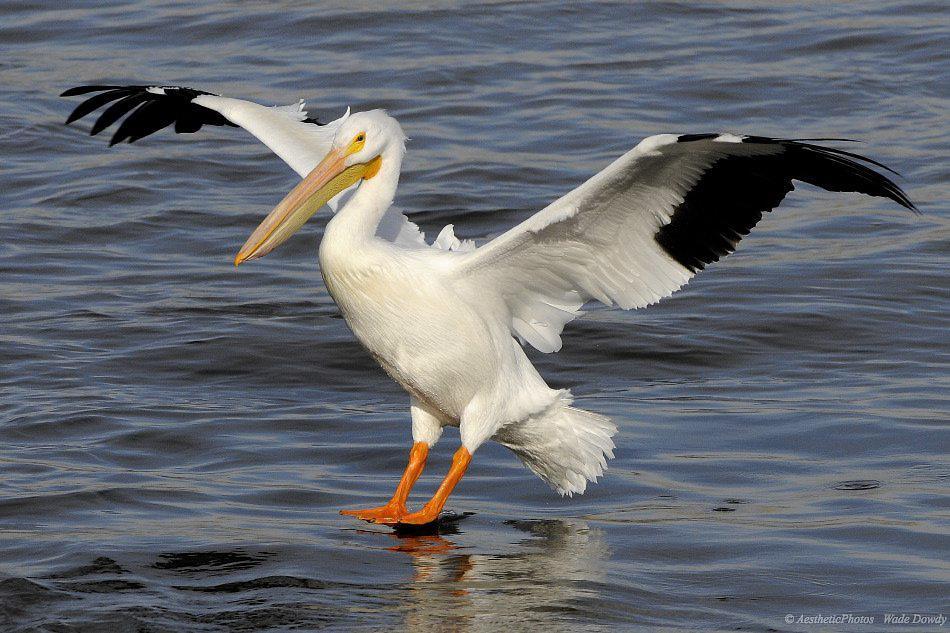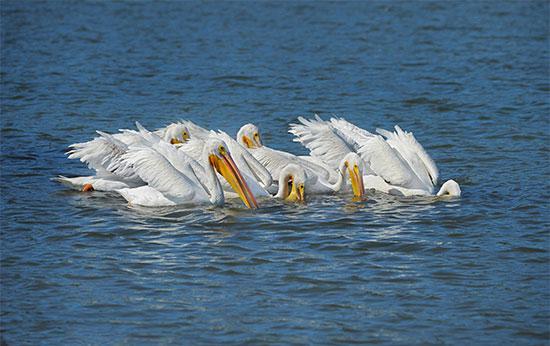The first image is the image on the left, the second image is the image on the right. Examine the images to the left and right. Is the description "A pelican with wings outstretched has an empty bill." accurate? Answer yes or no. Yes. 